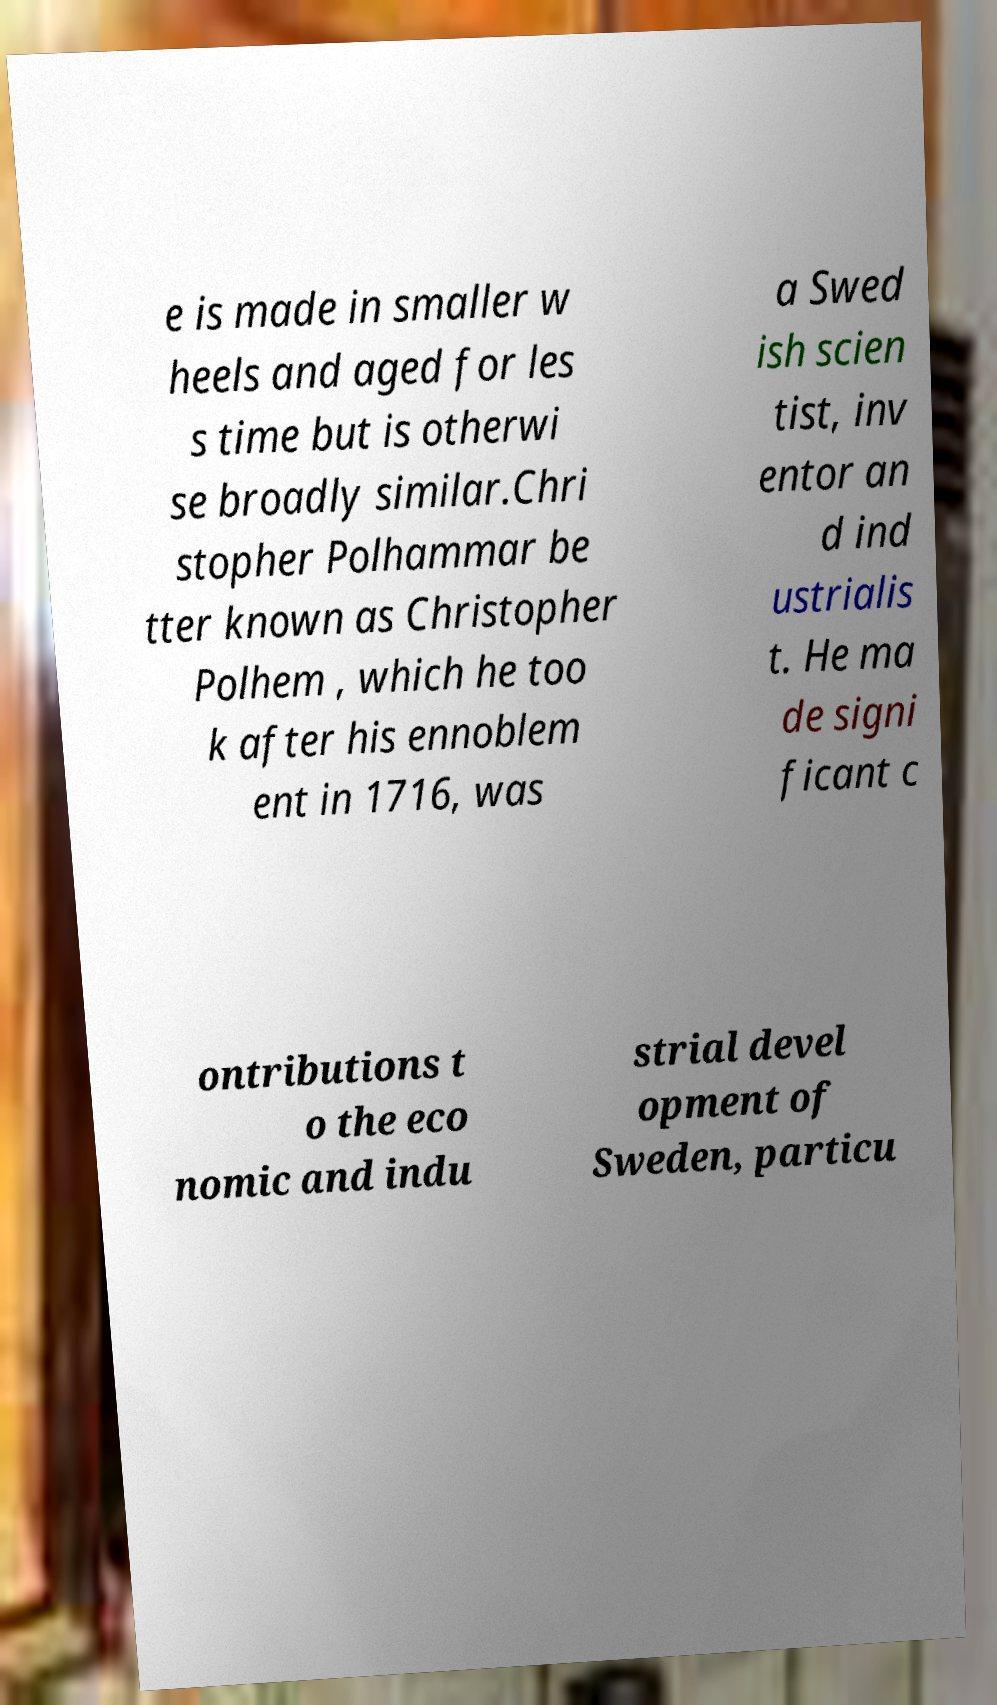For documentation purposes, I need the text within this image transcribed. Could you provide that? e is made in smaller w heels and aged for les s time but is otherwi se broadly similar.Chri stopher Polhammar be tter known as Christopher Polhem , which he too k after his ennoblem ent in 1716, was a Swed ish scien tist, inv entor an d ind ustrialis t. He ma de signi ficant c ontributions t o the eco nomic and indu strial devel opment of Sweden, particu 